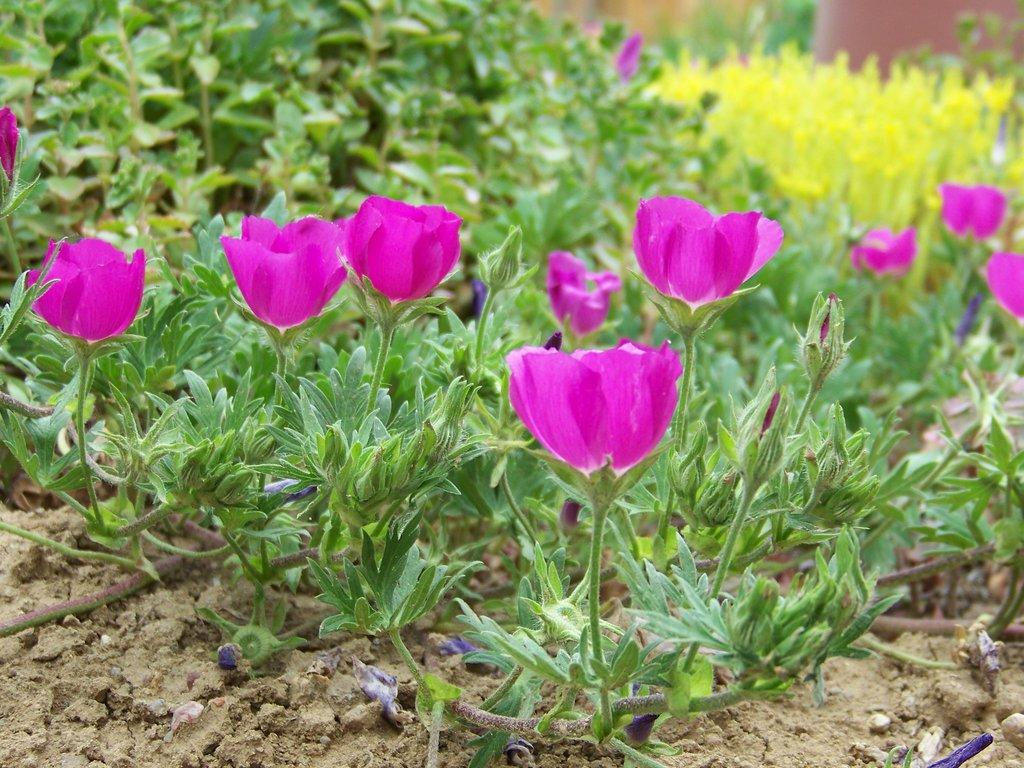What color are the flowers that are visible in the image? The flowers in the image are pink. What type of vegetation can be seen on the ground in the image? There are plants on the ground in the image. What color are the flowers in the background of the image? The flowers in the background of the image are yellow. What type of body part can be seen controlling the flowers in the image? There is no body part or control mechanism present in the image; the flowers are simply growing and blooming. 